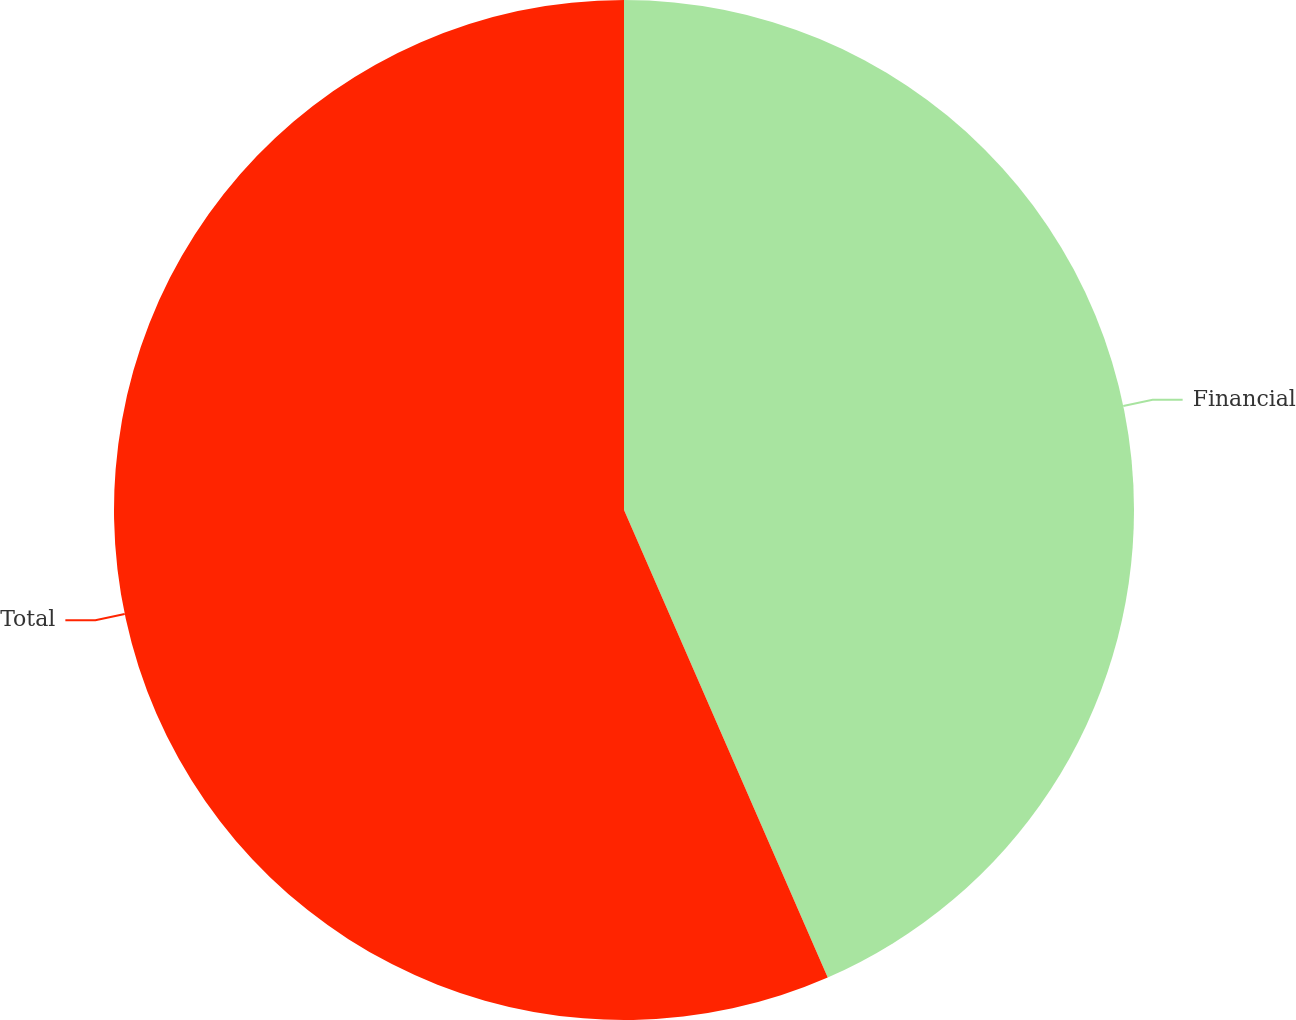<chart> <loc_0><loc_0><loc_500><loc_500><pie_chart><fcel>Financial<fcel>Total<nl><fcel>43.46%<fcel>56.54%<nl></chart> 